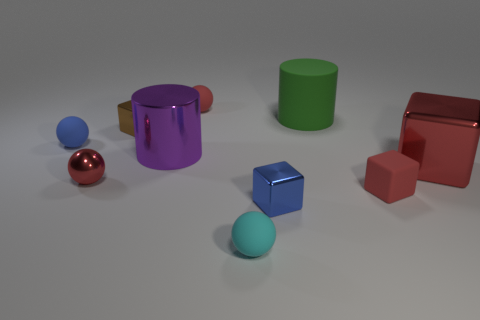There is a metallic thing that is in front of the red shiny sphere; is it the same color as the rubber ball on the left side of the tiny red metal object?
Your response must be concise. Yes. Is there a tiny block that has the same color as the big metal cube?
Your answer should be very brief. Yes. There is another cube that is the same color as the tiny rubber block; what is its material?
Give a very brief answer. Metal. How many objects are either red objects in front of the blue matte ball or red blocks?
Your answer should be very brief. 3. The tiny cube that is the same material as the small cyan ball is what color?
Ensure brevity in your answer.  Red. Are there any cyan spheres of the same size as the blue sphere?
Make the answer very short. Yes. How many things are either tiny things that are right of the cyan sphere or small blocks in front of the large red metal object?
Give a very brief answer. 2. The cyan matte thing that is the same size as the shiny ball is what shape?
Offer a very short reply. Sphere. Is there a blue metal thing of the same shape as the big green thing?
Provide a short and direct response. No. Are there fewer large purple cylinders than large green metal cubes?
Ensure brevity in your answer.  No. 